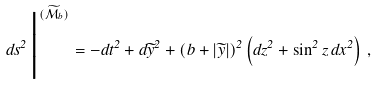Convert formula to latex. <formula><loc_0><loc_0><loc_500><loc_500>d s ^ { 2 } \, \Big | ^ { ( \widetilde { \mathcal { M } } _ { b } ) } = - d t ^ { 2 } + d \widetilde { y } ^ { 2 } + ( b + | \widetilde { y } | ) ^ { 2 } \left ( d z ^ { 2 } + \sin ^ { 2 } z \, d x ^ { 2 } \right ) \, ,</formula> 